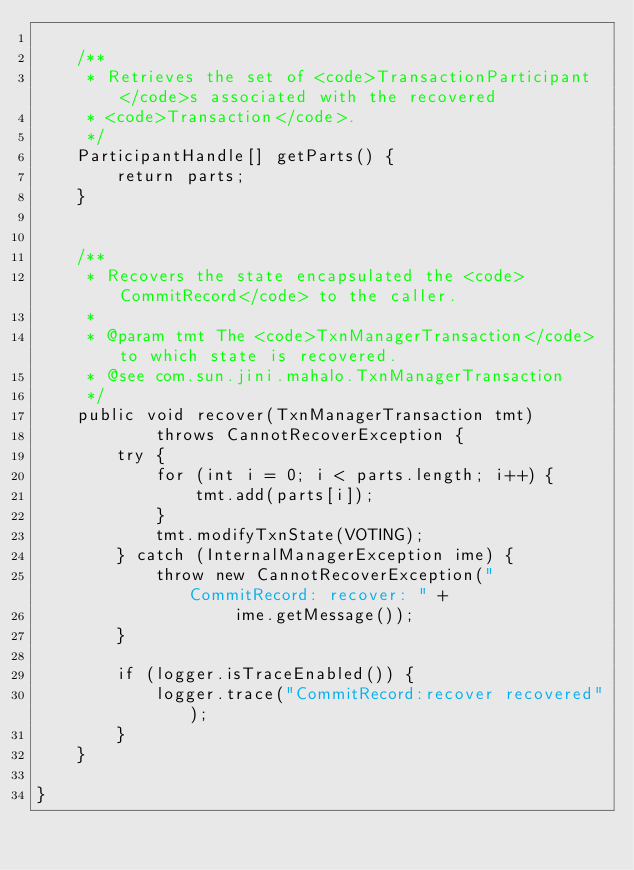<code> <loc_0><loc_0><loc_500><loc_500><_Java_>
    /**
     * Retrieves the set of <code>TransactionParticipant</code>s associated with the recovered
     * <code>Transaction</code>.
     */
    ParticipantHandle[] getParts() {
        return parts;
    }


    /**
     * Recovers the state encapsulated the <code>CommitRecord</code> to the caller.
     *
     * @param tmt The <code>TxnManagerTransaction</code> to which state is recovered.
     * @see com.sun.jini.mahalo.TxnManagerTransaction
     */
    public void recover(TxnManagerTransaction tmt)
            throws CannotRecoverException {
        try {
            for (int i = 0; i < parts.length; i++) {
                tmt.add(parts[i]);
            }
            tmt.modifyTxnState(VOTING);
        } catch (InternalManagerException ime) {
            throw new CannotRecoverException("CommitRecord: recover: " +
                    ime.getMessage());
        }

        if (logger.isTraceEnabled()) {
            logger.trace("CommitRecord:recover recovered");
        }
    }

}
</code> 